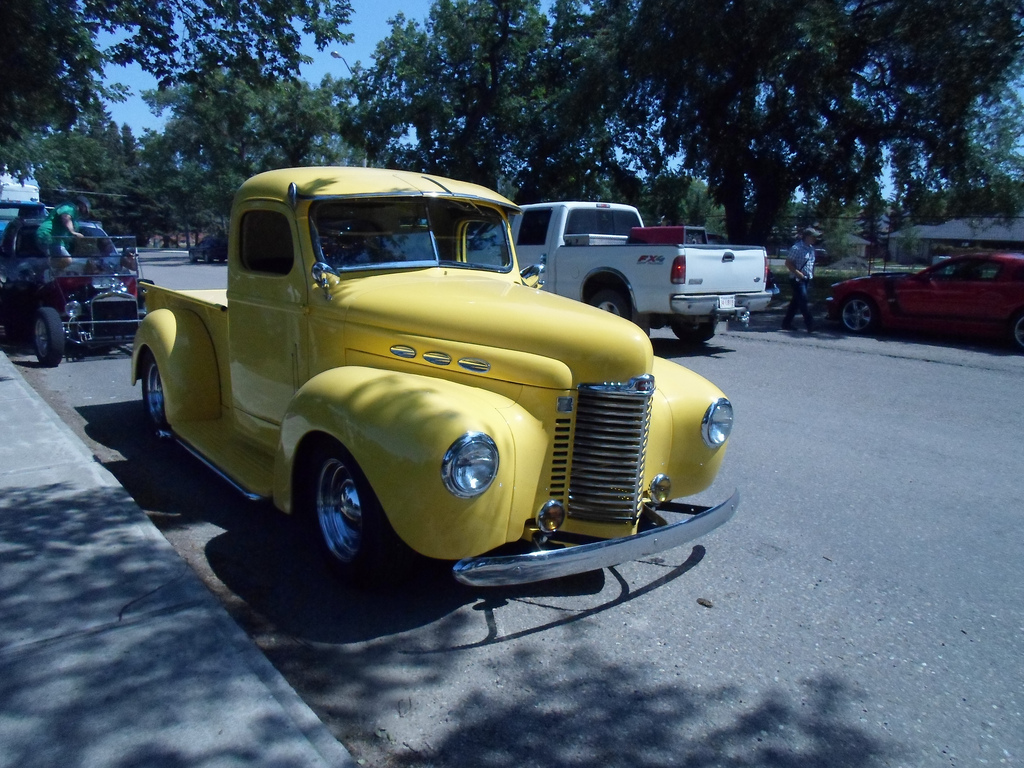What vehicle is to the right of the man?
Answer the question using a single word or phrase. Car Is the red car to the right or to the left of the white vehicle? Right What color does the car to the left of the other car have? Maroon Where was the picture taken? Pavement What type of vehicle is to the left of the person that is wearing a cap? Truck Is the man wearing a suit? No Who is wearing the cap? Man On which side is the man? Right Are there any surfboards or brooms? No Are there fences in this scene? No What are the vehicles to the right of the white vehicle? Cars Is the man to the left or to the right of the white vehicle? Right Is the red car to the right or to the left of the man? Right 